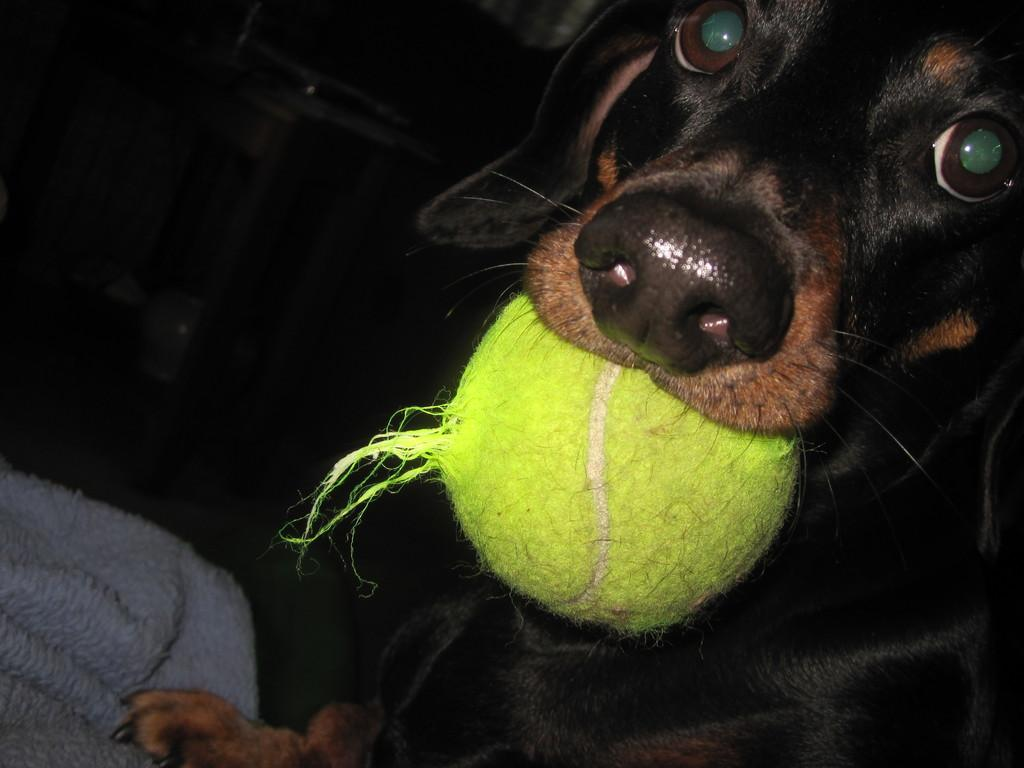What is the color of the background in the picture? The background of the picture is dark. Where is the dog located in the picture? The dog is on the right side of the picture. What is the dog doing in the picture? The dog is holding a ball in its mouth. What is on the left side of the picture? There is a cloth on the left side of the picture. How does the dog look at the twig in the picture? There is no twig present in the image, so the dog cannot be looking at a twig. 